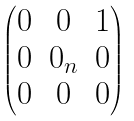Convert formula to latex. <formula><loc_0><loc_0><loc_500><loc_500>\begin{pmatrix} 0 & 0 & 1 \\ 0 & 0 _ { n } & 0 \\ 0 & 0 & 0 \end{pmatrix}</formula> 